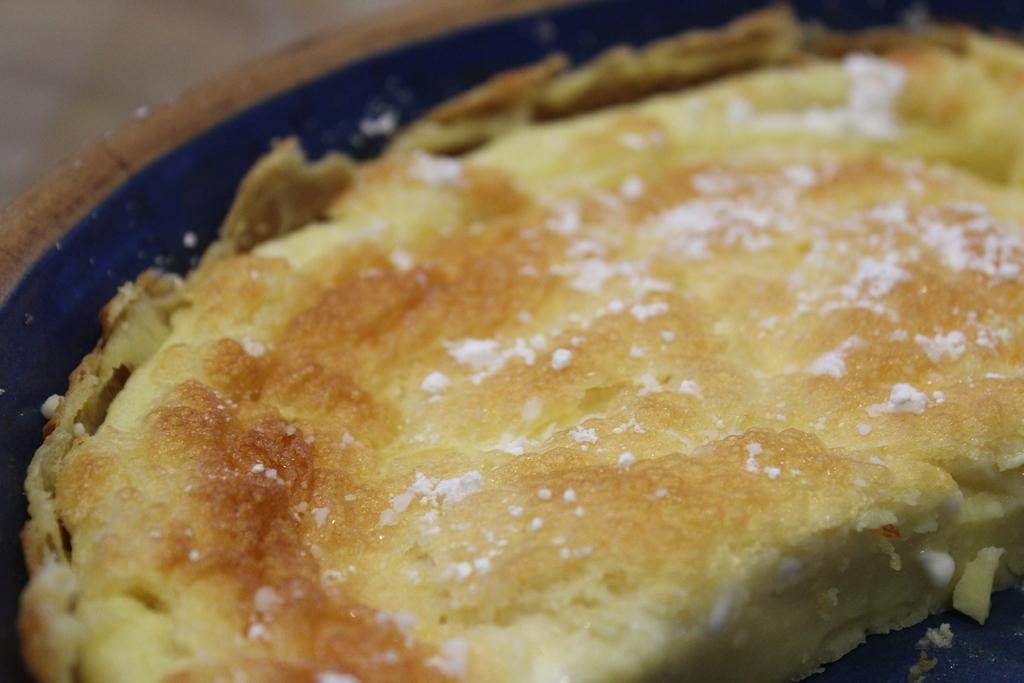Can you describe this image briefly? This is a zoomed in picture. In the center we can see a blue color object containing a food item. 